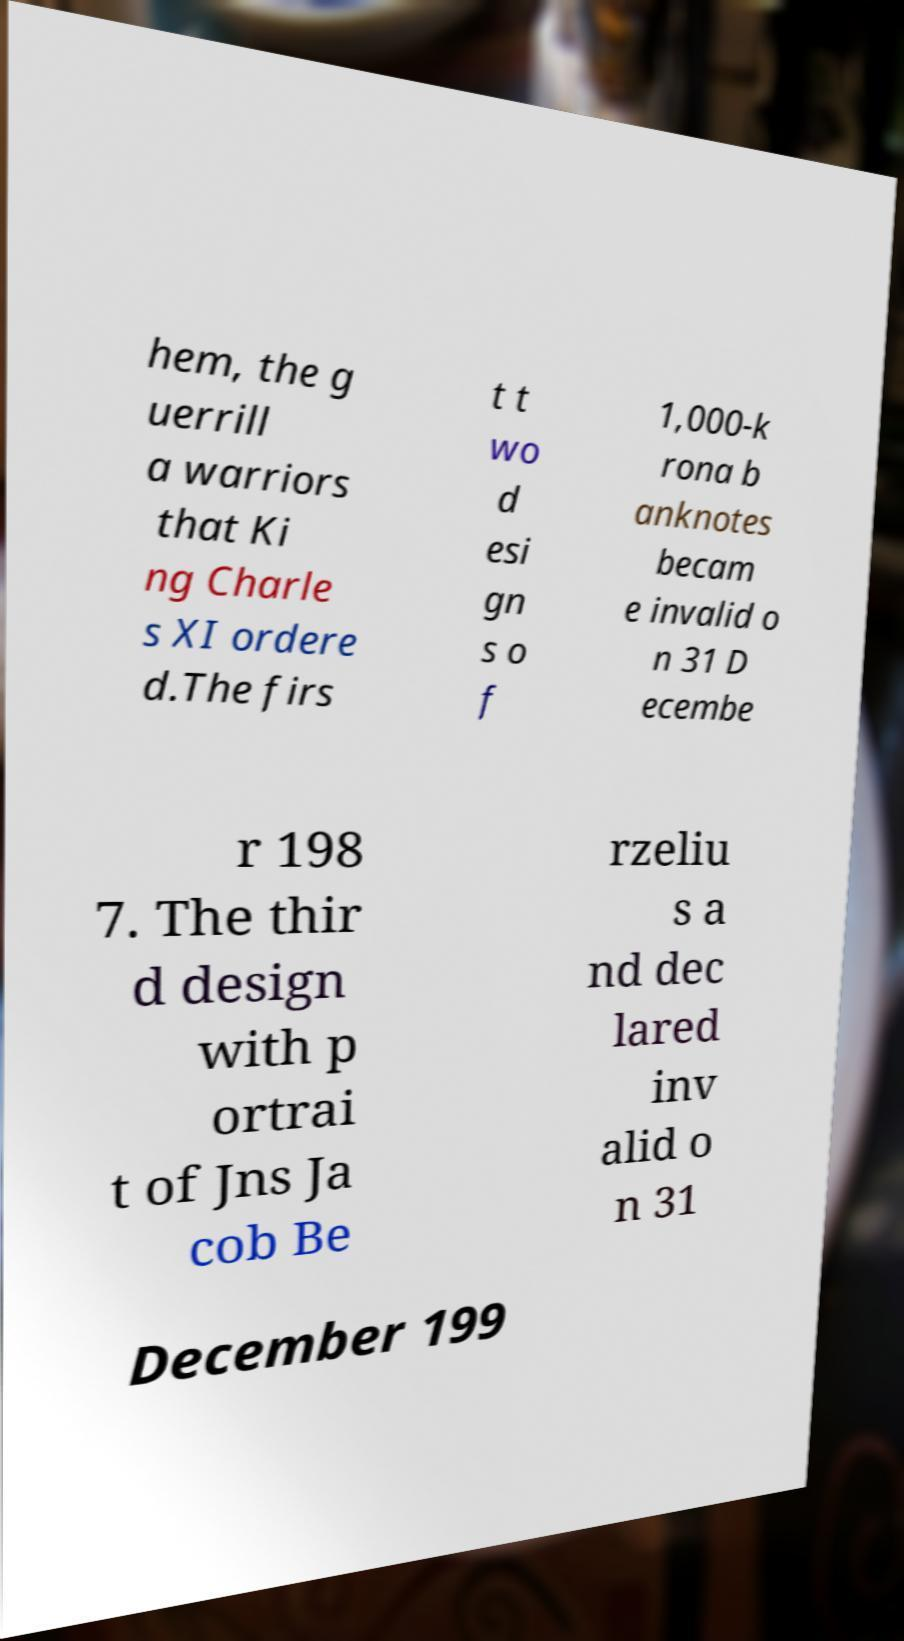Can you read and provide the text displayed in the image?This photo seems to have some interesting text. Can you extract and type it out for me? hem, the g uerrill a warriors that Ki ng Charle s XI ordere d.The firs t t wo d esi gn s o f 1,000-k rona b anknotes becam e invalid o n 31 D ecembe r 198 7. The thir d design with p ortrai t of Jns Ja cob Be rzeliu s a nd dec lared inv alid o n 31 December 199 